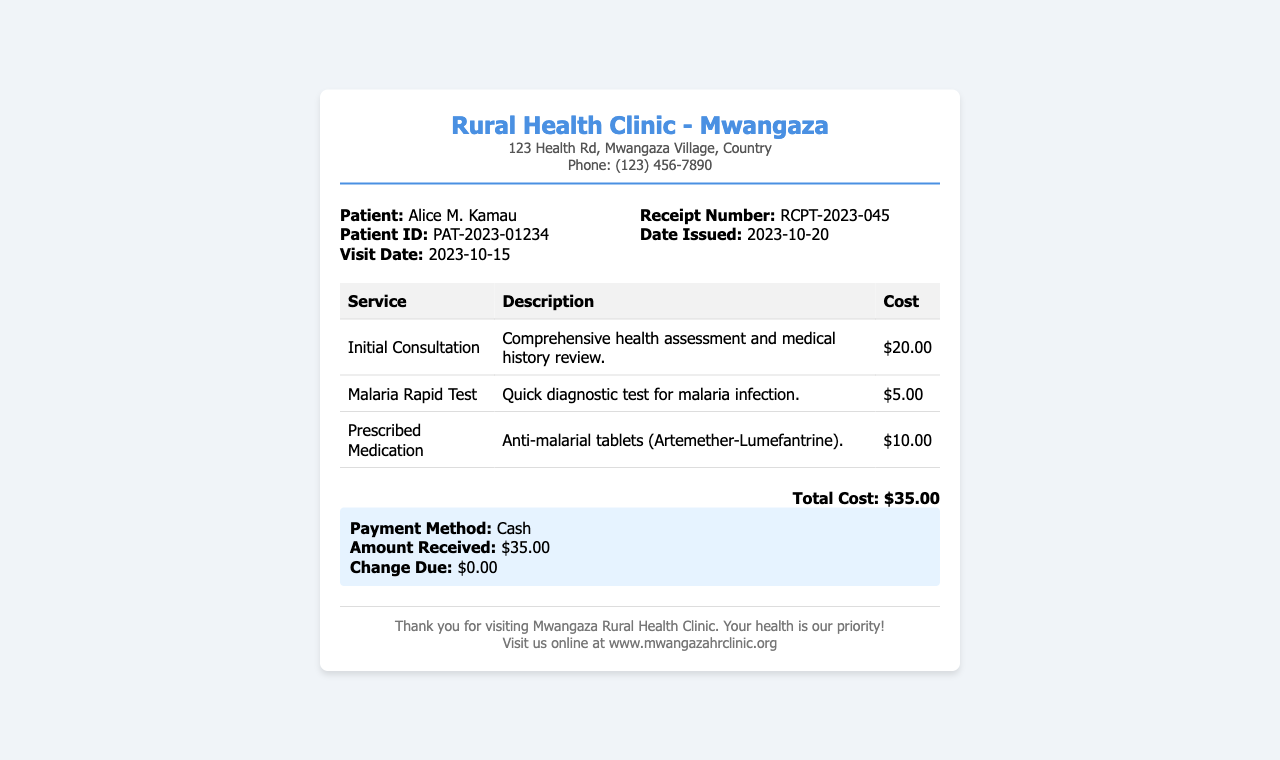What is the patient's name? The patient's name is stated clearly in the document.
Answer: Alice M. Kamau What is the visit date? The visit date is indicated in the patient information section.
Answer: 2023-10-15 How much did the initial consultation cost? The cost for the initial consultation is listed in the table of services provided.
Answer: $20.00 What is the total cost for the services? The total cost is shown prominently at the bottom of the receipt.
Answer: $35.00 What payment method was used? The payment method is outlined in the payment information section.
Answer: Cash What specific medication was prescribed? The prescribed medication is detailed in the table under medication services.
Answer: Anti-malarial tablets (Artemether-Lumefantrine) What is the receipt number? The receipt number is mentioned in the receipt information section.
Answer: RCPT-2023-045 How many services were provided in total? The number of services can be counted from the table of services listed.
Answer: 3 